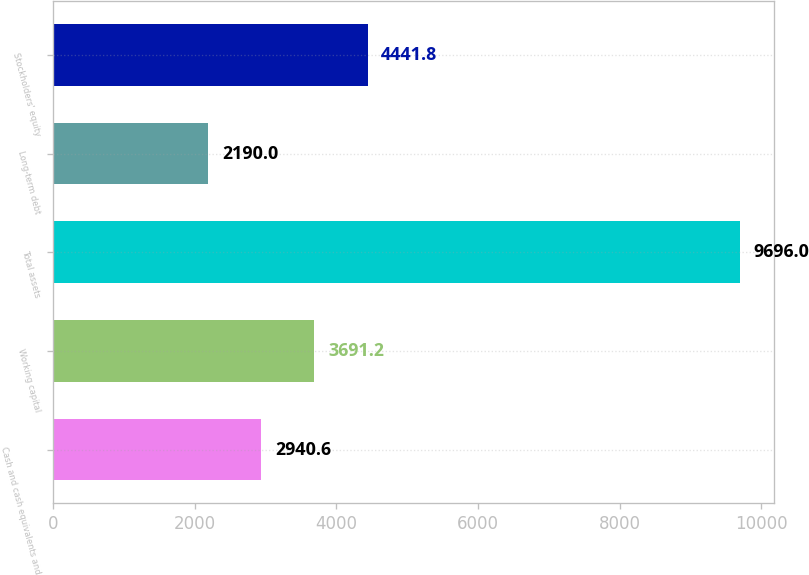Convert chart to OTSL. <chart><loc_0><loc_0><loc_500><loc_500><bar_chart><fcel>Cash and cash equivalents and<fcel>Working capital<fcel>Total assets<fcel>Long-term debt<fcel>Stockholders' equity<nl><fcel>2940.6<fcel>3691.2<fcel>9696<fcel>2190<fcel>4441.8<nl></chart> 